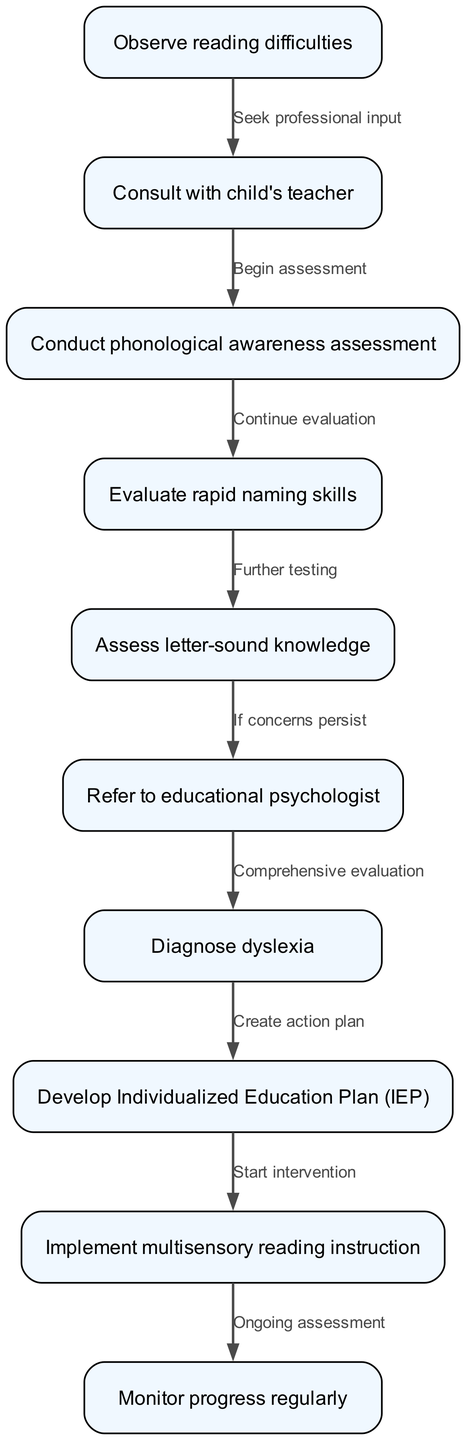What is the first step in the clinical pathway? The first step is to "Observe reading difficulties" as indicated in the diagram's starting node.
Answer: Observe reading difficulties How many nodes are in the pathway? By counting the items in the nodes section of the diagram, there are 10 distinct nodes present.
Answer: 10 What follows after consulting with the child's teacher? After consulting with the child's teacher, the next step is to "Conduct phonological awareness assessment" as shown in the connection from node 2 to node 3.
Answer: Conduct phonological awareness assessment What assessment comes after evaluating rapid naming skills? The assessment following "Evaluate rapid naming skills" is "Assess letter-sound knowledge," which is indicated in the flow from node 4 to node 5.
Answer: Assess letter-sound knowledge What action is taken if concerns persist? If concerns persist, the action taken is to "Refer to educational psychologist," as per the directed edge from node 5 to node 6.
Answer: Refer to educational psychologist How many edges are in the pathway? By counting the connections listed in the edges section of the diagram, there are 9 edges between the nodes representing the flow of the clinical pathway.
Answer: 9 What is created after diagnosing dyslexia? Upon diagnosis of dyslexia, the next action is to "Develop Individualized Education Plan (IEP)" which is the subsequent step in the pathway from node 7 to node 8.
Answer: Develop Individualized Education Plan (IEP) What type of instruction is implemented after developing the IEP? The type of instruction implemented after developing the IEP is "Implement multisensory reading instruction," which follows the diagram flow from node 8 to node 9.
Answer: Implement multisensory reading instruction What is the final step in the clinical pathway? The final step in this clinical pathway is "Monitor progress regularly," indicated by the transition from node 9 to node 10.
Answer: Monitor progress regularly 